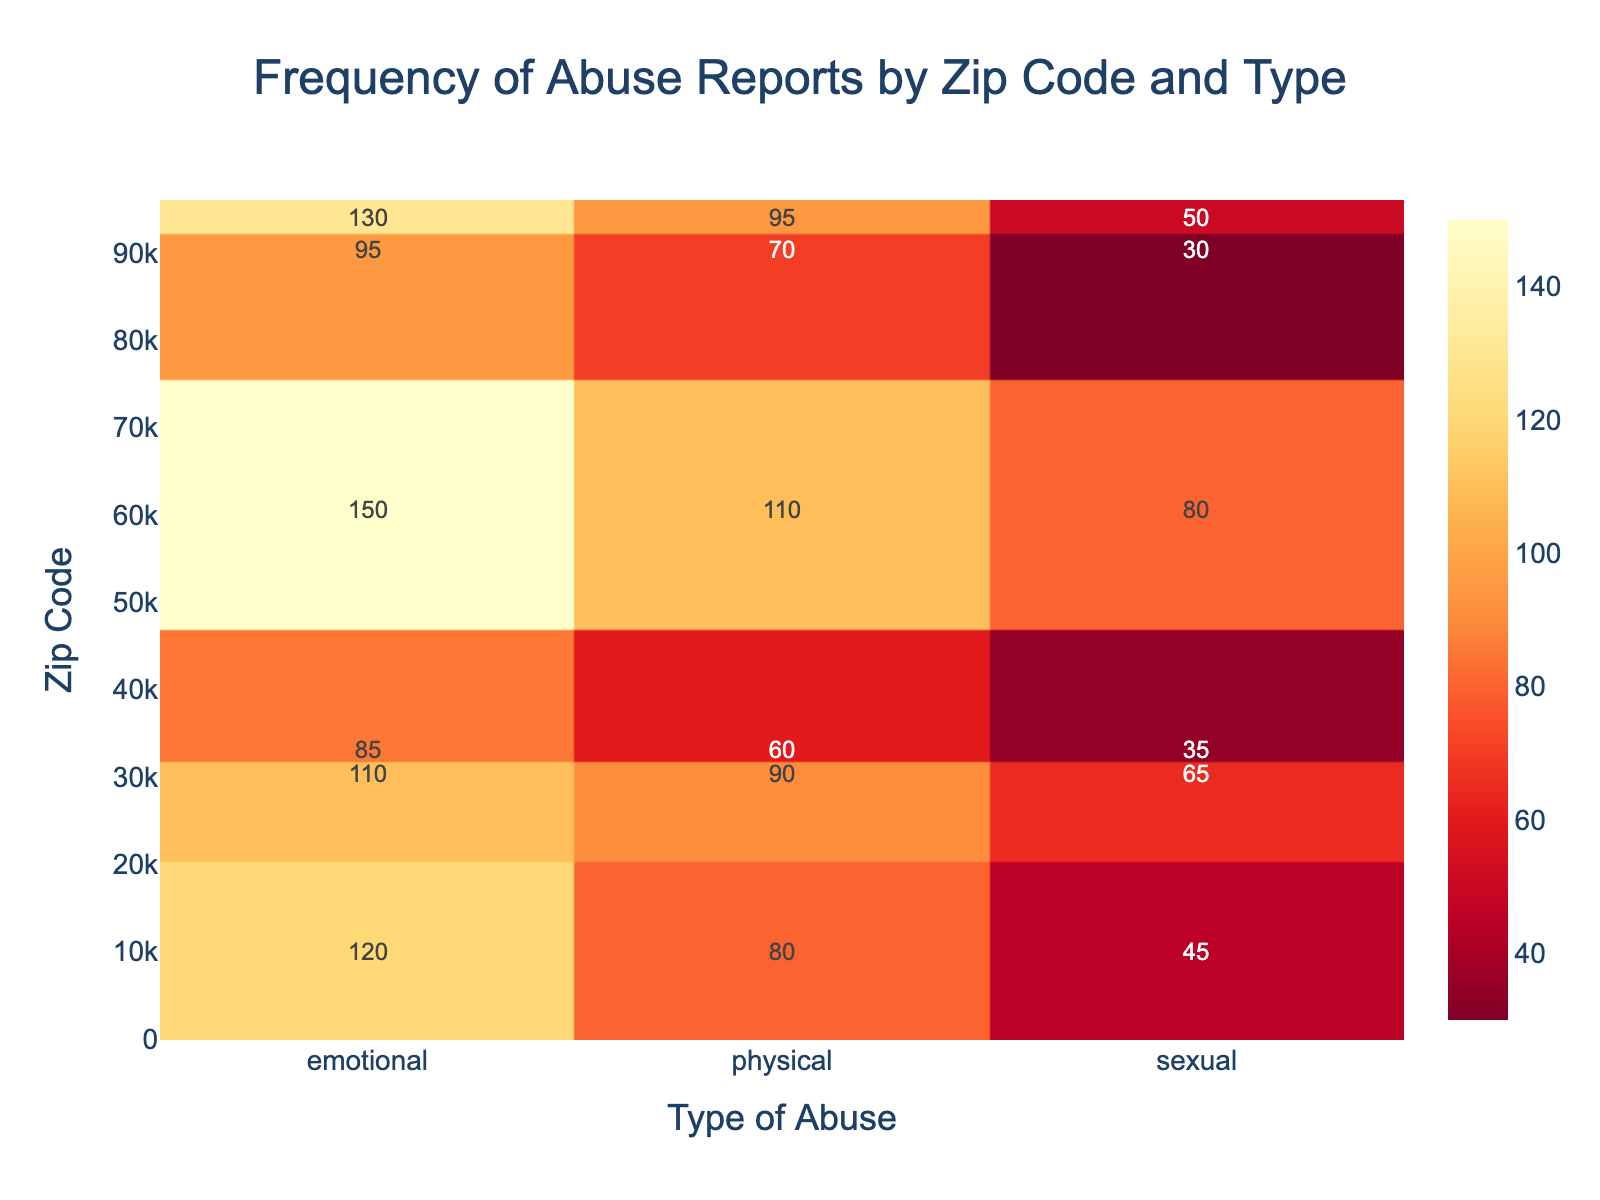What is the title of the heatmap? The title is typically found at the top center of the heatmap, usually larger in font size and distinctly colored. In this case, the title is "Frequency of Abuse Reports by Zip Code and Type."
Answer: Frequency of Abuse Reports by Zip Code and Type Which zip code has the highest frequency of physical abuse reports? To find this, look at the column for physical abuse and identify the row (zip code) with the highest value. The highest value in the physical abuse column is 110, which corresponds to zip code 60601.
Answer: 60601 How many zip codes are represented in the heatmap? The zip codes are listed along the vertical axis (y-axis). Count the unique zip codes listed to find the total number represented. There are six unique zip codes shown.
Answer: 6 What is the average frequency of sexual abuse reports across all zip codes? Identify the values for sexual abuse across all zip codes. Sum them up and divide by the number of zip codes (6). The values are 45, 30, 65, 80, 50, and 35. The sum is 305, and the average is 305/6 ≈ 50.83.
Answer: 50.83 Compare the frequency of emotional abuse reports between zip code 10001 and 90210. Which has a higher frequency and by how much? The emotional abuse frequency for 10001 is 120, and for 90210, it is 95. To compare, subtract the smaller number from the larger one: 120 - 95 = 25. Zip code 10001 has 25 more reports than 90210.
Answer: 10001 by 25 Which type of abuse has the lowest frequency in zip code 33101? Look at the row for zip code 33101 and identify the smallest value among the three types of abuse. The values are 85 for emotional, 60 for physical, and 35 for sexual abuse. The smallest value is 35, corresponding to sexual abuse.
Answer: Sexual What is the total frequency of abuse reports across all types for zip code 94102? Sum up the frequencies of all three types of abuse for zip code 94102. The values are 130 for emotional, 95 for physical, and 50 for sexual abuse. The total is 130 + 95 + 50 = 275.
Answer: 275 Is the frequency of emotional abuse in zip code 60601 greater than all types of abuse in zip code 33101? Compare the emotional abuse frequency in 60601 (150) with each type of abuse in 33101. In 33101, the frequencies are 85 (emotional), 60 (physical), and 35 (sexual). Since 150 is greater than all these values, the answer is yes.
Answer: Yes What is the difference in frequency between physical abuse reports in zip code 90210 and zip code 30301? Identify the physical abuse frequency for both zip codes (90210: 70, 30301: 90). Subtract the smaller number from the larger one to find the difference: 90 - 70 = 20.
Answer: 20 Which zip code has the highest combined frequency for all types of abuse? Sum the frequencies of all types of abuse for each zip code, then identify the highest sum. Zip code 60601 has the highest combined frequency (150 + 110 + 80 = 340).
Answer: 60601 